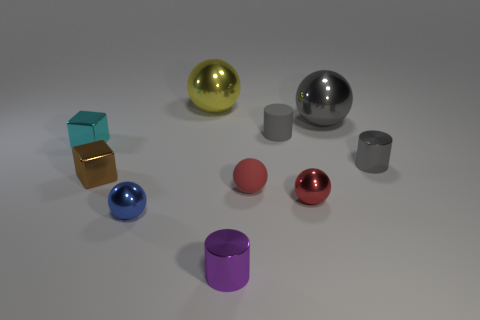Subtract all blue balls. How many balls are left? 4 Subtract all gray balls. How many balls are left? 4 Subtract 1 cylinders. How many cylinders are left? 2 Subtract all cylinders. How many objects are left? 7 Subtract all purple cylinders. How many cyan cubes are left? 1 Add 2 tiny blocks. How many tiny blocks are left? 4 Add 2 gray cylinders. How many gray cylinders exist? 4 Subtract 0 brown spheres. How many objects are left? 10 Subtract all red cylinders. Subtract all purple balls. How many cylinders are left? 3 Subtract all tiny matte spheres. Subtract all purple things. How many objects are left? 8 